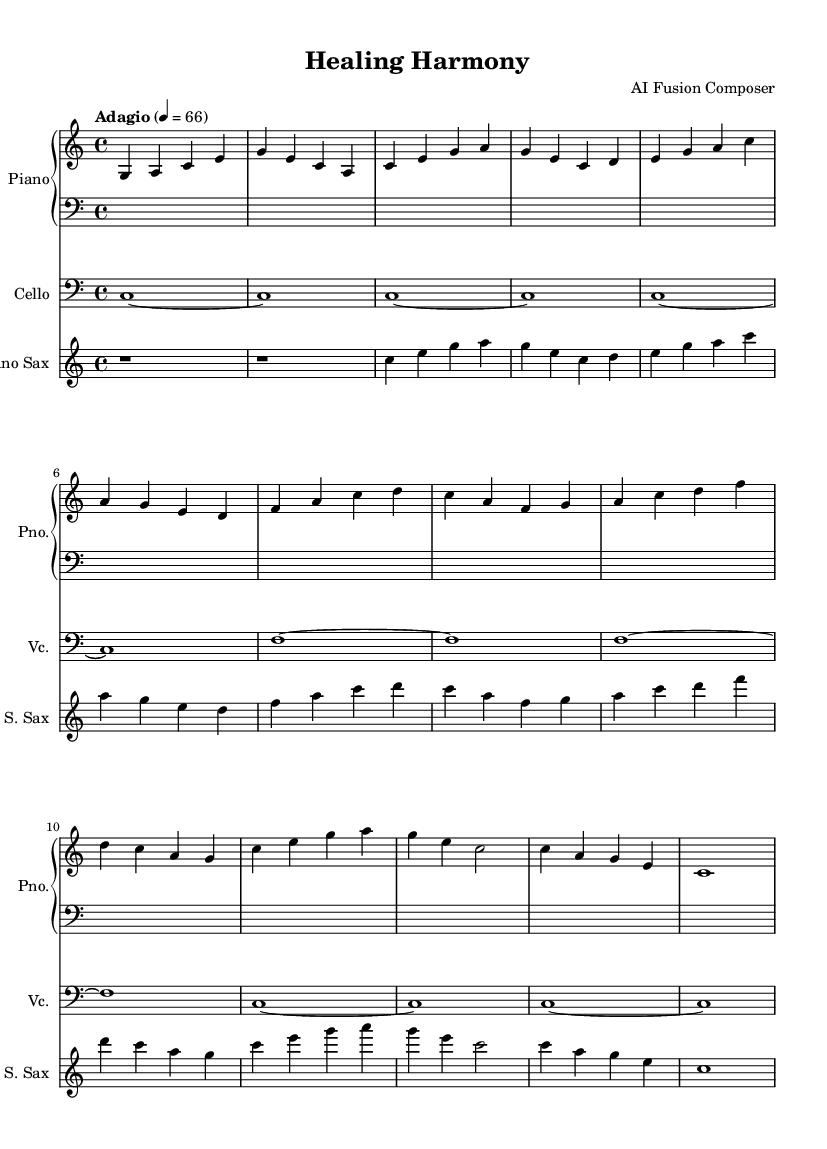What is the key signature of this music? The key signature is C major, which indicates no sharps or flats in the music. It's identified by the absence of any sharps or flats right after the clef sign.
Answer: C major What is the time signature of this music? The time signature is 4/4, meaning there are four beats per measure, and the quarter note receives one beat. This is noted on the left side of the staff right after the key signature.
Answer: 4/4 What is the tempo marking of this music? The tempo marking is "Adagio," and the specific tempo indicated is quarter note equals 66 beats per minute, which contributes to a slow and relaxed feel. It's written above the staff at the beginning of the score.
Answer: Adagio How many measures does the piano part have? By counting the individual measures in the piano staff, there are a total of 12 measures. Each measure is separated by vertical lines.
Answer: 12 Which instrument plays the melody in this piece? The soprano saxophone plays the melody, as it carries the main melodic lines above the harmony provided by the piano and cello. This can be inferred by looking at the melodic contours in the saxophone part.
Answer: Soprano Sax What type of musical fusion is represented in this piece? The music represents a fusion of jazz and classical elements, characterized by improvisation and harmonic richness typical in jazz, combined with structured forms and harmonies from classical music. This is evident from the instrumentation and stylistic choices.
Answer: Jazz-Classical What is the dynamic marking for the cello part? The cello part does not have dynamic markings indicated, which often suggests a soft and sustained sound throughout. This can be confirmed by checking the cello staff for any written dynamics.
Answer: None (soft) 